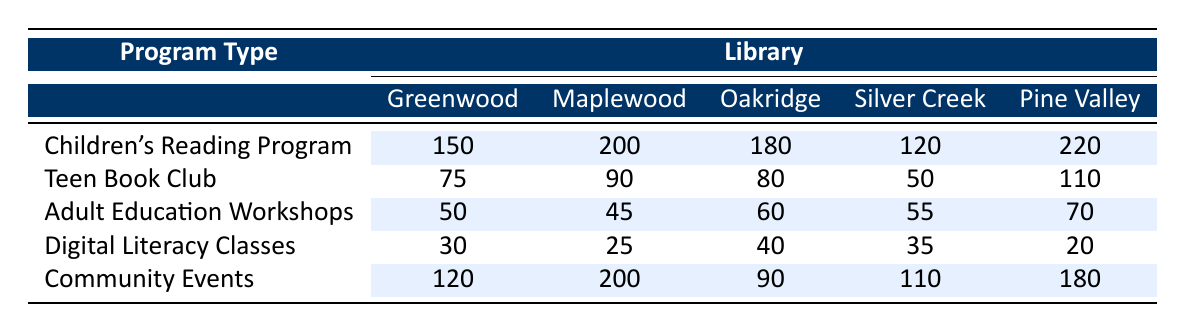What is the highest usage rate for the Children's Reading Program? The highest value for the Children's Reading Program can be found by comparing all library usage rates for that program. The values are 150, 200, 180, 120, and 220. The highest is 220 from Pine Valley Library.
Answer: 220 Which library had the lowest usage rate for Digital Literacy Classes? By looking at the Digital Literacy Classes usage rates, the values are 30, 25, 40, 35, and 20. The lowest is 20 from Pine Valley Library.
Answer: 20 What is the total usage rate for all Community Events across all libraries? To find the total usage rate for Community Events, sum all the values: 120 + 200 + 90 + 110 + 180 = 700.
Answer: 700 Which program type has the highest overall average usage rate across all libraries? First, sum each program's usage rates: 
- Children's Reading Program: 150 + 200 + 180 + 120 + 220 = 870
- Teen Book Club: 75 + 90 + 80 + 50 + 110 = 405
- Adult Education Workshops: 50 + 45 + 60 + 55 + 70 = 280
- Digital Literacy Classes: 30 + 25 + 40 + 35 + 20 = 150
- Community Events: 120 + 200 + 90 + 110 + 180 = 700
Then, calculate the average for each program by dividing by 5.
- Children's Reading Program: 870/5 = 174
- Teen Book Club: 405/5 = 81
- Adult Education Workshops: 280/5 = 56
- Digital Literacy Classes: 150/5 = 30
- Community Events: 700/5 = 140
The highest average is for the Children's Reading Program at 174.
Answer: Children's Reading Program Is the Adult Education Workshops program more popular than the Teen Book Club program in any library? We compare the usage rates for both programs per library: 
- Greenwood: Adult Ed (50) vs. Teen Club (75) - No
- Maplewood: Adult Ed (45) vs. Teen Club (90) - No
- Oakridge: Adult Ed (60) vs. Teen Club (80) - No
- Silver Creek: Adult Ed (55) vs. Teen Club (50) - Yes
- Pine Valley: Adult Ed (70) vs. Teen Club (110) - No
Thus, Adult Education Workshops is more popular than Teen Book Club only in Silver Creek Library.
Answer: Yes What percentage of the total usage rates does the Pine Valley Library contribute to all library programs combined? First, calculate Pine Valley's total usage rate: 220 + 110 + 70 + 20 + 180 = 610. Then, calculate the overall total of all libraries combined: 
Greenwood: 150 + 75 + 50 + 30 + 120 = 425 
Maplewood: 200 + 90 + 45 + 25 + 200 = 550 
Oakridge: 180 + 80 + 60 + 40 + 90 = 450 
Silver Creek: 120 + 50 + 55 + 35 + 110 = 370 
Pine Valley: 610
Adding these gives 425 + 550 + 450 + 370 + 610 = 2405. 
Now, calculate Pine Valley's contribution percentage: (610/2405) * 100 ≈ 25.4%.
Answer: 25.4% 